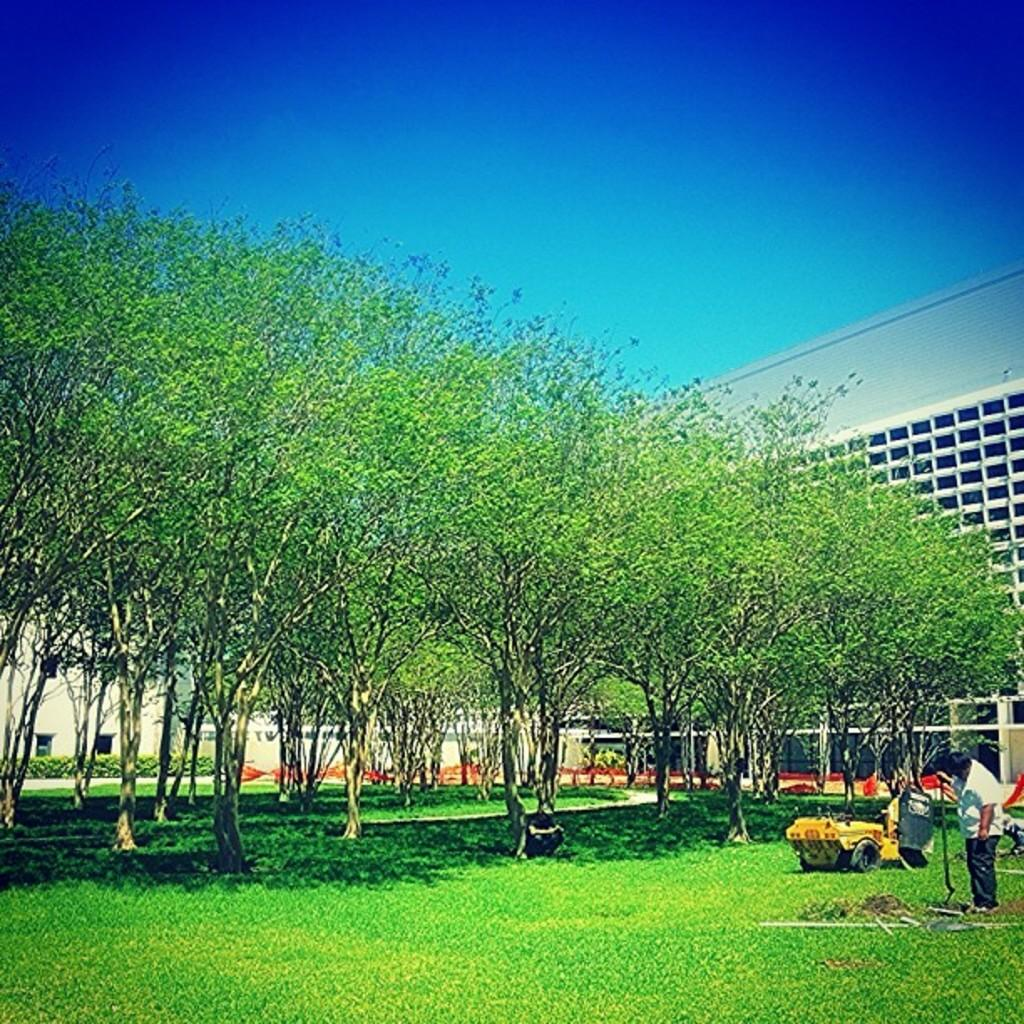How many buildings can be seen in the image? There are two buildings in the image. What is the person in the image doing? The person is standing and holding an object. What color is the sky in the image? The sky is blue in the image. What type of vegetation is present in the image? There are many trees in the image. What type of pancake is the person holding in the image? There is no pancake present in the image; the person is holding an object, but it is not a pancake. 